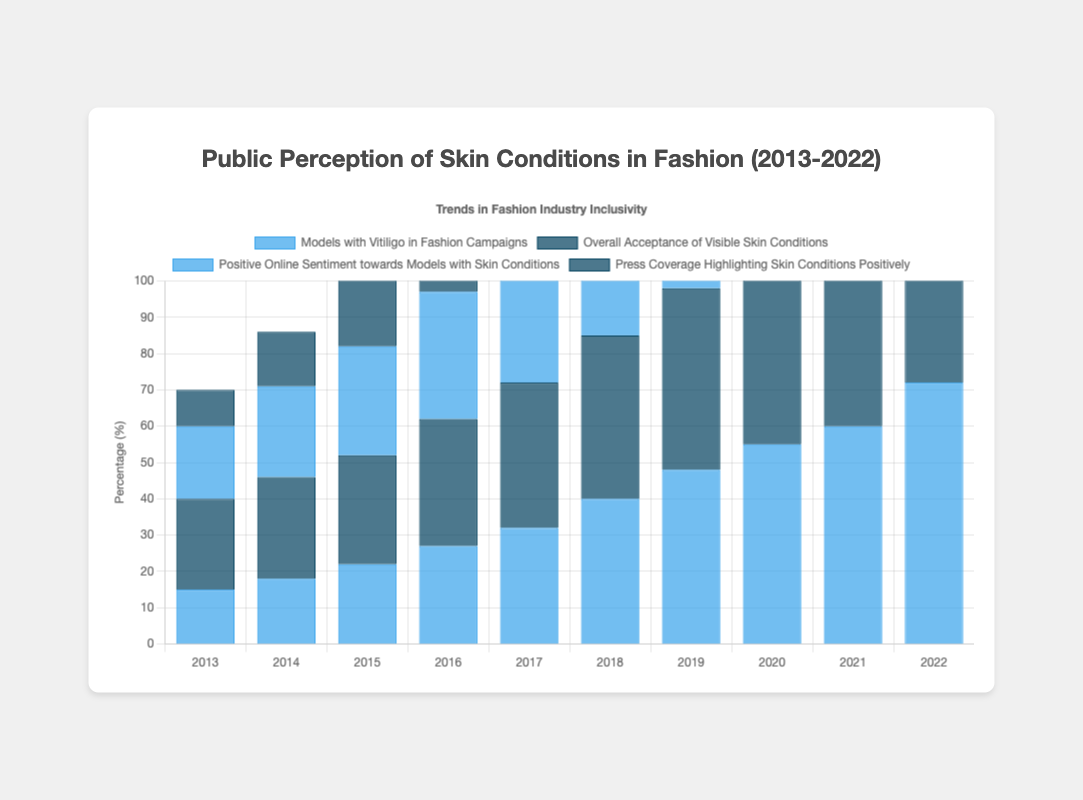What is the trend in the percentage of "Models with Vitiligo in Fashion Campaigns" from 2013 to 2022? The trend shows a continuous increase in the percentage, starting from 15% in 2013 and reaching 72% in 2022.
Answer: Continuous increase Which year shows the highest percentage of "Positive Online Sentiment towards Models with Skin Conditions"? The highest percentage of Positive Online Sentiment is in 2022 with 77%.
Answer: 2022 How does the percentage of "Press Coverage Highlighting Skin Conditions Positively" compare between 2013 and 2022? The percentage increased from 10% in 2013 to 68% in 2022.
Answer: Increased In 2017, which entity had the highest percentage? In 2017, "Overall Acceptance of Visible Skin Conditions" had the highest percentage at 40%.
Answer: Overall Acceptance of Visible Skin Conditions Calculate the average percentage of "Models with Vitiligo in Fashion Campaigns" over the decade. Sum the percentages (15+18+22+27+32+40+48+55+60+72) which equals 389. Divide by 10.
Answer: 38.9% Which has grown more from 2013 to 2022, "Overall Acceptance of Visible Skin Conditions" or "Models with Vitiligo in Fashion Campaigns"? "Models with Vitiligo in Fashion Campaigns" grew from 15% to 72% while "Overall Acceptance of Visible Skin Conditions" grew from 25% to 70%. The growth of the former is 57%, and the growth of the latter is 45%.
Answer: Models with Vitiligo in Fashion Campaigns Compare the patterns of "Press Coverage Highlighting Skin Conditions Positively" and "Positive Online Sentiment towards Models with Skin Conditions". Both show an upward trend, but positive online sentiment has a sharper increase, especially from 2018-2022 where it surpasses press coverage in 2019.
Answer: Both increased, online sentiment sharper What color represents "Overall Acceptance of Visible Skin Conditions"? The color representing "Overall Acceptance of Visible Skin Conditions" is dark blue.
Answer: Dark blue In which year did "Models with Vitiligo in Fashion Campaigns" and "Positive Online Sentiment towards Models with Skin Conditions" have the same percentage? In 2016, both entities had the same percentage of 35%.
Answer: 2016 